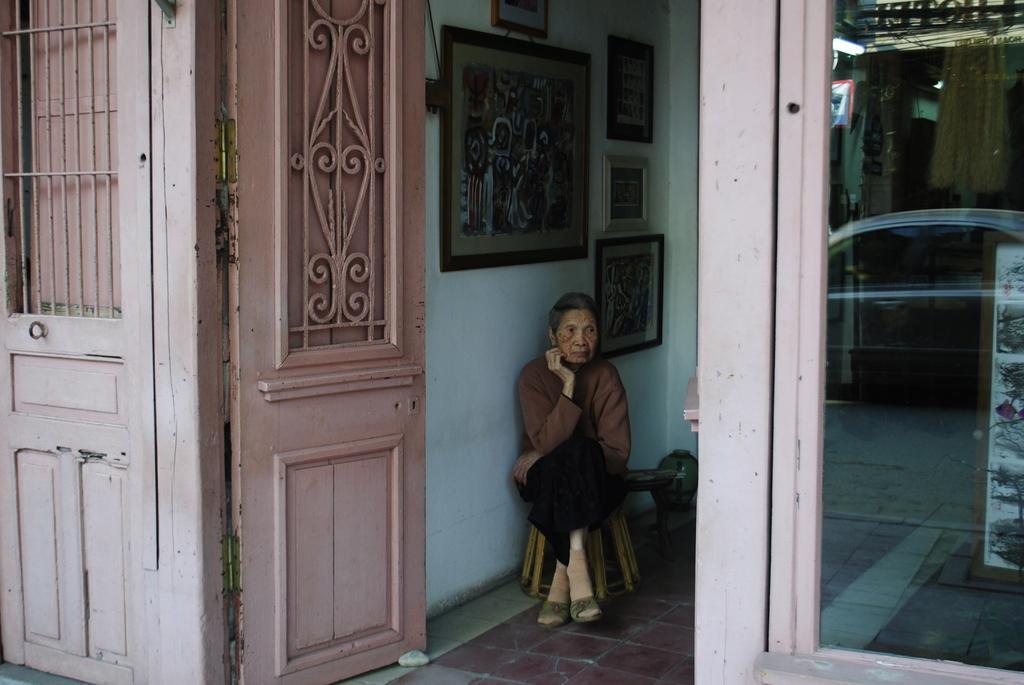Describe this image in one or two sentences. In this image there is a person sitting on the chair. Behind her there are photo frames on the wall. There are doors. There is a glass door through which we can see a painting on the board, light and a few other objects. 